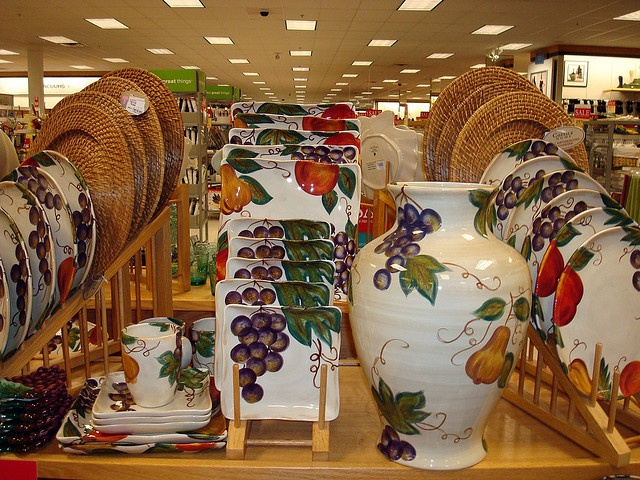Describe the objects in this image and their specific colors. I can see vase in maroon, darkgray, and tan tones, cup in maroon and tan tones, cup in maroon, black, and gray tones, and cup in maroon, black, darkgray, and gray tones in this image. 